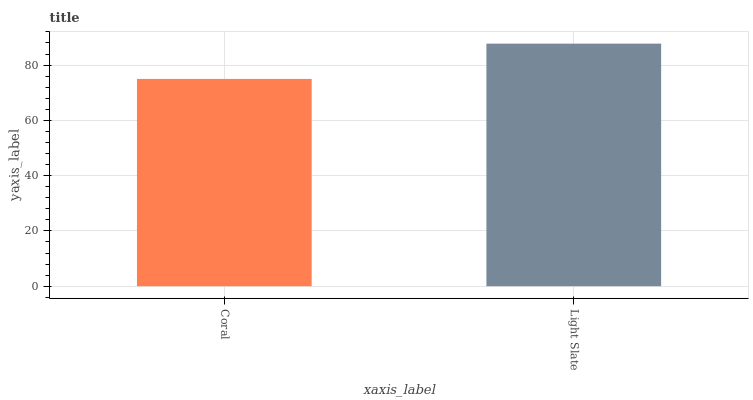Is Coral the minimum?
Answer yes or no. Yes. Is Light Slate the maximum?
Answer yes or no. Yes. Is Light Slate the minimum?
Answer yes or no. No. Is Light Slate greater than Coral?
Answer yes or no. Yes. Is Coral less than Light Slate?
Answer yes or no. Yes. Is Coral greater than Light Slate?
Answer yes or no. No. Is Light Slate less than Coral?
Answer yes or no. No. Is Light Slate the high median?
Answer yes or no. Yes. Is Coral the low median?
Answer yes or no. Yes. Is Coral the high median?
Answer yes or no. No. Is Light Slate the low median?
Answer yes or no. No. 